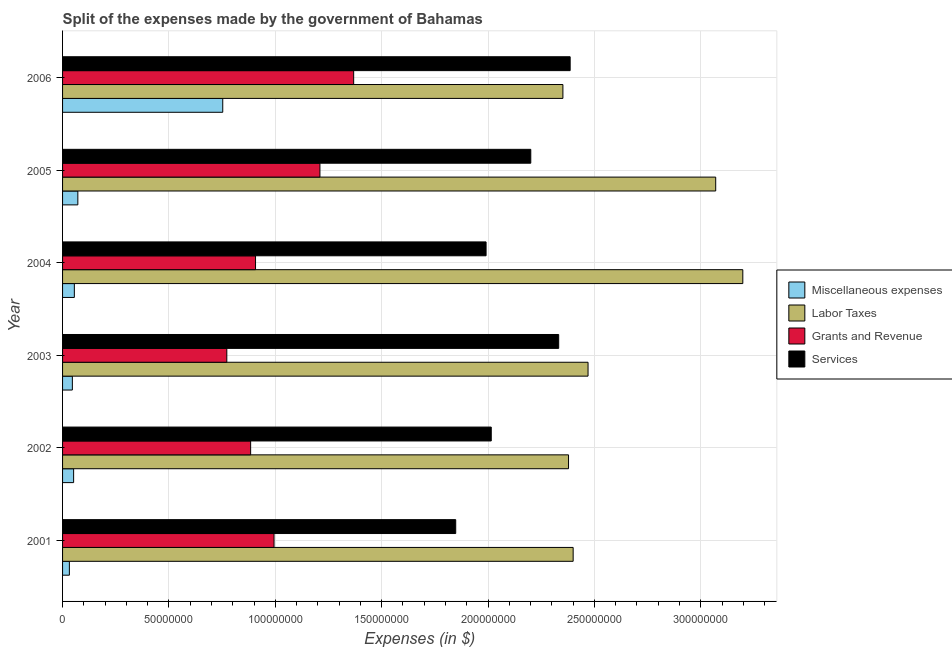Are the number of bars per tick equal to the number of legend labels?
Your response must be concise. Yes. How many bars are there on the 1st tick from the bottom?
Offer a very short reply. 4. In how many cases, is the number of bars for a given year not equal to the number of legend labels?
Your answer should be compact. 0. What is the amount spent on grants and revenue in 2005?
Provide a short and direct response. 1.21e+08. Across all years, what is the maximum amount spent on services?
Offer a very short reply. 2.39e+08. Across all years, what is the minimum amount spent on grants and revenue?
Ensure brevity in your answer.  7.72e+07. In which year was the amount spent on services minimum?
Make the answer very short. 2001. What is the total amount spent on miscellaneous expenses in the graph?
Your response must be concise. 1.01e+08. What is the difference between the amount spent on labor taxes in 2001 and that in 2003?
Your answer should be compact. -7.00e+06. What is the difference between the amount spent on services in 2003 and the amount spent on miscellaneous expenses in 2002?
Make the answer very short. 2.28e+08. What is the average amount spent on grants and revenue per year?
Keep it short and to the point. 1.02e+08. In the year 2005, what is the difference between the amount spent on grants and revenue and amount spent on services?
Your answer should be compact. -9.91e+07. In how many years, is the amount spent on services greater than 210000000 $?
Provide a short and direct response. 3. What is the ratio of the amount spent on miscellaneous expenses in 2001 to that in 2004?
Ensure brevity in your answer.  0.58. Is the amount spent on miscellaneous expenses in 2003 less than that in 2006?
Provide a succinct answer. Yes. Is the difference between the amount spent on services in 2001 and 2002 greater than the difference between the amount spent on grants and revenue in 2001 and 2002?
Offer a very short reply. No. What is the difference between the highest and the second highest amount spent on services?
Offer a very short reply. 5.39e+06. What is the difference between the highest and the lowest amount spent on miscellaneous expenses?
Your answer should be compact. 7.21e+07. What does the 2nd bar from the top in 2002 represents?
Your response must be concise. Grants and Revenue. What does the 1st bar from the bottom in 2001 represents?
Your response must be concise. Miscellaneous expenses. Is it the case that in every year, the sum of the amount spent on miscellaneous expenses and amount spent on labor taxes is greater than the amount spent on grants and revenue?
Make the answer very short. Yes. Are all the bars in the graph horizontal?
Provide a short and direct response. Yes. What is the difference between two consecutive major ticks on the X-axis?
Offer a terse response. 5.00e+07. Are the values on the major ticks of X-axis written in scientific E-notation?
Keep it short and to the point. No. Does the graph contain grids?
Provide a short and direct response. Yes. Where does the legend appear in the graph?
Provide a short and direct response. Center right. What is the title of the graph?
Your response must be concise. Split of the expenses made by the government of Bahamas. Does "Secondary vocational" appear as one of the legend labels in the graph?
Your response must be concise. No. What is the label or title of the X-axis?
Give a very brief answer. Expenses (in $). What is the label or title of the Y-axis?
Offer a terse response. Year. What is the Expenses (in $) in Miscellaneous expenses in 2001?
Provide a short and direct response. 3.20e+06. What is the Expenses (in $) in Labor Taxes in 2001?
Ensure brevity in your answer.  2.40e+08. What is the Expenses (in $) in Grants and Revenue in 2001?
Ensure brevity in your answer.  9.94e+07. What is the Expenses (in $) in Services in 2001?
Your answer should be compact. 1.85e+08. What is the Expenses (in $) of Miscellaneous expenses in 2002?
Offer a terse response. 5.20e+06. What is the Expenses (in $) in Labor Taxes in 2002?
Give a very brief answer. 2.38e+08. What is the Expenses (in $) in Grants and Revenue in 2002?
Provide a short and direct response. 8.84e+07. What is the Expenses (in $) of Services in 2002?
Keep it short and to the point. 2.02e+08. What is the Expenses (in $) in Miscellaneous expenses in 2003?
Offer a very short reply. 4.60e+06. What is the Expenses (in $) of Labor Taxes in 2003?
Offer a terse response. 2.47e+08. What is the Expenses (in $) of Grants and Revenue in 2003?
Keep it short and to the point. 7.72e+07. What is the Expenses (in $) in Services in 2003?
Offer a very short reply. 2.33e+08. What is the Expenses (in $) of Miscellaneous expenses in 2004?
Keep it short and to the point. 5.54e+06. What is the Expenses (in $) in Labor Taxes in 2004?
Provide a short and direct response. 3.20e+08. What is the Expenses (in $) of Grants and Revenue in 2004?
Your answer should be very brief. 9.07e+07. What is the Expenses (in $) of Services in 2004?
Your response must be concise. 1.99e+08. What is the Expenses (in $) of Miscellaneous expenses in 2005?
Offer a very short reply. 7.18e+06. What is the Expenses (in $) in Labor Taxes in 2005?
Make the answer very short. 3.07e+08. What is the Expenses (in $) in Grants and Revenue in 2005?
Your answer should be very brief. 1.21e+08. What is the Expenses (in $) of Services in 2005?
Ensure brevity in your answer.  2.20e+08. What is the Expenses (in $) of Miscellaneous expenses in 2006?
Your response must be concise. 7.53e+07. What is the Expenses (in $) in Labor Taxes in 2006?
Your answer should be compact. 2.35e+08. What is the Expenses (in $) of Grants and Revenue in 2006?
Offer a very short reply. 1.37e+08. What is the Expenses (in $) in Services in 2006?
Your answer should be compact. 2.39e+08. Across all years, what is the maximum Expenses (in $) in Miscellaneous expenses?
Ensure brevity in your answer.  7.53e+07. Across all years, what is the maximum Expenses (in $) in Labor Taxes?
Ensure brevity in your answer.  3.20e+08. Across all years, what is the maximum Expenses (in $) in Grants and Revenue?
Offer a terse response. 1.37e+08. Across all years, what is the maximum Expenses (in $) of Services?
Offer a very short reply. 2.39e+08. Across all years, what is the minimum Expenses (in $) of Miscellaneous expenses?
Your answer should be very brief. 3.20e+06. Across all years, what is the minimum Expenses (in $) of Labor Taxes?
Provide a succinct answer. 2.35e+08. Across all years, what is the minimum Expenses (in $) in Grants and Revenue?
Your response must be concise. 7.72e+07. Across all years, what is the minimum Expenses (in $) of Services?
Provide a short and direct response. 1.85e+08. What is the total Expenses (in $) of Miscellaneous expenses in the graph?
Provide a short and direct response. 1.01e+08. What is the total Expenses (in $) of Labor Taxes in the graph?
Your response must be concise. 1.59e+09. What is the total Expenses (in $) of Grants and Revenue in the graph?
Ensure brevity in your answer.  6.14e+08. What is the total Expenses (in $) in Services in the graph?
Offer a terse response. 1.28e+09. What is the difference between the Expenses (in $) of Miscellaneous expenses in 2001 and that in 2002?
Your answer should be compact. -2.00e+06. What is the difference between the Expenses (in $) in Labor Taxes in 2001 and that in 2002?
Keep it short and to the point. 2.18e+06. What is the difference between the Expenses (in $) in Grants and Revenue in 2001 and that in 2002?
Provide a short and direct response. 1.10e+07. What is the difference between the Expenses (in $) of Services in 2001 and that in 2002?
Make the answer very short. -1.67e+07. What is the difference between the Expenses (in $) of Miscellaneous expenses in 2001 and that in 2003?
Give a very brief answer. -1.40e+06. What is the difference between the Expenses (in $) in Labor Taxes in 2001 and that in 2003?
Give a very brief answer. -7.00e+06. What is the difference between the Expenses (in $) in Grants and Revenue in 2001 and that in 2003?
Your answer should be very brief. 2.22e+07. What is the difference between the Expenses (in $) in Services in 2001 and that in 2003?
Your answer should be compact. -4.84e+07. What is the difference between the Expenses (in $) in Miscellaneous expenses in 2001 and that in 2004?
Provide a succinct answer. -2.34e+06. What is the difference between the Expenses (in $) in Labor Taxes in 2001 and that in 2004?
Make the answer very short. -7.97e+07. What is the difference between the Expenses (in $) in Grants and Revenue in 2001 and that in 2004?
Provide a short and direct response. 8.70e+06. What is the difference between the Expenses (in $) in Services in 2001 and that in 2004?
Make the answer very short. -1.43e+07. What is the difference between the Expenses (in $) of Miscellaneous expenses in 2001 and that in 2005?
Keep it short and to the point. -3.98e+06. What is the difference between the Expenses (in $) of Labor Taxes in 2001 and that in 2005?
Offer a terse response. -6.70e+07. What is the difference between the Expenses (in $) in Grants and Revenue in 2001 and that in 2005?
Offer a terse response. -2.16e+07. What is the difference between the Expenses (in $) in Services in 2001 and that in 2005?
Your response must be concise. -3.53e+07. What is the difference between the Expenses (in $) in Miscellaneous expenses in 2001 and that in 2006?
Offer a very short reply. -7.21e+07. What is the difference between the Expenses (in $) in Labor Taxes in 2001 and that in 2006?
Offer a terse response. 4.82e+06. What is the difference between the Expenses (in $) in Grants and Revenue in 2001 and that in 2006?
Make the answer very short. -3.74e+07. What is the difference between the Expenses (in $) in Services in 2001 and that in 2006?
Provide a short and direct response. -5.38e+07. What is the difference between the Expenses (in $) in Labor Taxes in 2002 and that in 2003?
Your answer should be very brief. -9.18e+06. What is the difference between the Expenses (in $) of Grants and Revenue in 2002 and that in 2003?
Your answer should be compact. 1.12e+07. What is the difference between the Expenses (in $) of Services in 2002 and that in 2003?
Your answer should be very brief. -3.17e+07. What is the difference between the Expenses (in $) in Miscellaneous expenses in 2002 and that in 2004?
Keep it short and to the point. -3.39e+05. What is the difference between the Expenses (in $) of Labor Taxes in 2002 and that in 2004?
Offer a very short reply. -8.19e+07. What is the difference between the Expenses (in $) of Grants and Revenue in 2002 and that in 2004?
Offer a very short reply. -2.30e+06. What is the difference between the Expenses (in $) in Services in 2002 and that in 2004?
Ensure brevity in your answer.  2.43e+06. What is the difference between the Expenses (in $) in Miscellaneous expenses in 2002 and that in 2005?
Offer a terse response. -1.98e+06. What is the difference between the Expenses (in $) in Labor Taxes in 2002 and that in 2005?
Make the answer very short. -6.92e+07. What is the difference between the Expenses (in $) of Grants and Revenue in 2002 and that in 2005?
Give a very brief answer. -3.26e+07. What is the difference between the Expenses (in $) in Services in 2002 and that in 2005?
Keep it short and to the point. -1.86e+07. What is the difference between the Expenses (in $) of Miscellaneous expenses in 2002 and that in 2006?
Ensure brevity in your answer.  -7.01e+07. What is the difference between the Expenses (in $) in Labor Taxes in 2002 and that in 2006?
Ensure brevity in your answer.  2.64e+06. What is the difference between the Expenses (in $) of Grants and Revenue in 2002 and that in 2006?
Provide a succinct answer. -4.84e+07. What is the difference between the Expenses (in $) of Services in 2002 and that in 2006?
Offer a terse response. -3.71e+07. What is the difference between the Expenses (in $) in Miscellaneous expenses in 2003 and that in 2004?
Your answer should be very brief. -9.39e+05. What is the difference between the Expenses (in $) in Labor Taxes in 2003 and that in 2004?
Provide a short and direct response. -7.27e+07. What is the difference between the Expenses (in $) in Grants and Revenue in 2003 and that in 2004?
Your response must be concise. -1.35e+07. What is the difference between the Expenses (in $) of Services in 2003 and that in 2004?
Offer a terse response. 3.41e+07. What is the difference between the Expenses (in $) in Miscellaneous expenses in 2003 and that in 2005?
Your response must be concise. -2.58e+06. What is the difference between the Expenses (in $) of Labor Taxes in 2003 and that in 2005?
Make the answer very short. -6.00e+07. What is the difference between the Expenses (in $) of Grants and Revenue in 2003 and that in 2005?
Your answer should be compact. -4.38e+07. What is the difference between the Expenses (in $) of Services in 2003 and that in 2005?
Give a very brief answer. 1.31e+07. What is the difference between the Expenses (in $) in Miscellaneous expenses in 2003 and that in 2006?
Provide a succinct answer. -7.07e+07. What is the difference between the Expenses (in $) of Labor Taxes in 2003 and that in 2006?
Your answer should be very brief. 1.18e+07. What is the difference between the Expenses (in $) in Grants and Revenue in 2003 and that in 2006?
Make the answer very short. -5.96e+07. What is the difference between the Expenses (in $) in Services in 2003 and that in 2006?
Keep it short and to the point. -5.39e+06. What is the difference between the Expenses (in $) of Miscellaneous expenses in 2004 and that in 2005?
Your response must be concise. -1.64e+06. What is the difference between the Expenses (in $) in Labor Taxes in 2004 and that in 2005?
Give a very brief answer. 1.27e+07. What is the difference between the Expenses (in $) in Grants and Revenue in 2004 and that in 2005?
Make the answer very short. -3.03e+07. What is the difference between the Expenses (in $) in Services in 2004 and that in 2005?
Ensure brevity in your answer.  -2.10e+07. What is the difference between the Expenses (in $) in Miscellaneous expenses in 2004 and that in 2006?
Provide a short and direct response. -6.98e+07. What is the difference between the Expenses (in $) of Labor Taxes in 2004 and that in 2006?
Ensure brevity in your answer.  8.46e+07. What is the difference between the Expenses (in $) in Grants and Revenue in 2004 and that in 2006?
Keep it short and to the point. -4.61e+07. What is the difference between the Expenses (in $) of Services in 2004 and that in 2006?
Offer a terse response. -3.95e+07. What is the difference between the Expenses (in $) in Miscellaneous expenses in 2005 and that in 2006?
Your answer should be compact. -6.81e+07. What is the difference between the Expenses (in $) in Labor Taxes in 2005 and that in 2006?
Your response must be concise. 7.18e+07. What is the difference between the Expenses (in $) of Grants and Revenue in 2005 and that in 2006?
Your answer should be compact. -1.59e+07. What is the difference between the Expenses (in $) in Services in 2005 and that in 2006?
Ensure brevity in your answer.  -1.85e+07. What is the difference between the Expenses (in $) in Miscellaneous expenses in 2001 and the Expenses (in $) in Labor Taxes in 2002?
Offer a very short reply. -2.35e+08. What is the difference between the Expenses (in $) in Miscellaneous expenses in 2001 and the Expenses (in $) in Grants and Revenue in 2002?
Offer a terse response. -8.52e+07. What is the difference between the Expenses (in $) in Miscellaneous expenses in 2001 and the Expenses (in $) in Services in 2002?
Make the answer very short. -1.98e+08. What is the difference between the Expenses (in $) in Labor Taxes in 2001 and the Expenses (in $) in Grants and Revenue in 2002?
Offer a very short reply. 1.52e+08. What is the difference between the Expenses (in $) in Labor Taxes in 2001 and the Expenses (in $) in Services in 2002?
Offer a very short reply. 3.85e+07. What is the difference between the Expenses (in $) of Grants and Revenue in 2001 and the Expenses (in $) of Services in 2002?
Your answer should be very brief. -1.02e+08. What is the difference between the Expenses (in $) of Miscellaneous expenses in 2001 and the Expenses (in $) of Labor Taxes in 2003?
Keep it short and to the point. -2.44e+08. What is the difference between the Expenses (in $) of Miscellaneous expenses in 2001 and the Expenses (in $) of Grants and Revenue in 2003?
Make the answer very short. -7.40e+07. What is the difference between the Expenses (in $) of Miscellaneous expenses in 2001 and the Expenses (in $) of Services in 2003?
Give a very brief answer. -2.30e+08. What is the difference between the Expenses (in $) of Labor Taxes in 2001 and the Expenses (in $) of Grants and Revenue in 2003?
Keep it short and to the point. 1.63e+08. What is the difference between the Expenses (in $) in Labor Taxes in 2001 and the Expenses (in $) in Services in 2003?
Provide a succinct answer. 6.80e+06. What is the difference between the Expenses (in $) in Grants and Revenue in 2001 and the Expenses (in $) in Services in 2003?
Make the answer very short. -1.34e+08. What is the difference between the Expenses (in $) of Miscellaneous expenses in 2001 and the Expenses (in $) of Labor Taxes in 2004?
Provide a succinct answer. -3.17e+08. What is the difference between the Expenses (in $) of Miscellaneous expenses in 2001 and the Expenses (in $) of Grants and Revenue in 2004?
Give a very brief answer. -8.75e+07. What is the difference between the Expenses (in $) in Miscellaneous expenses in 2001 and the Expenses (in $) in Services in 2004?
Provide a short and direct response. -1.96e+08. What is the difference between the Expenses (in $) of Labor Taxes in 2001 and the Expenses (in $) of Grants and Revenue in 2004?
Provide a succinct answer. 1.49e+08. What is the difference between the Expenses (in $) in Labor Taxes in 2001 and the Expenses (in $) in Services in 2004?
Provide a short and direct response. 4.09e+07. What is the difference between the Expenses (in $) in Grants and Revenue in 2001 and the Expenses (in $) in Services in 2004?
Provide a short and direct response. -9.97e+07. What is the difference between the Expenses (in $) in Miscellaneous expenses in 2001 and the Expenses (in $) in Labor Taxes in 2005?
Offer a very short reply. -3.04e+08. What is the difference between the Expenses (in $) of Miscellaneous expenses in 2001 and the Expenses (in $) of Grants and Revenue in 2005?
Provide a succinct answer. -1.18e+08. What is the difference between the Expenses (in $) of Miscellaneous expenses in 2001 and the Expenses (in $) of Services in 2005?
Provide a succinct answer. -2.17e+08. What is the difference between the Expenses (in $) of Labor Taxes in 2001 and the Expenses (in $) of Grants and Revenue in 2005?
Offer a very short reply. 1.19e+08. What is the difference between the Expenses (in $) in Labor Taxes in 2001 and the Expenses (in $) in Services in 2005?
Ensure brevity in your answer.  1.99e+07. What is the difference between the Expenses (in $) in Grants and Revenue in 2001 and the Expenses (in $) in Services in 2005?
Your response must be concise. -1.21e+08. What is the difference between the Expenses (in $) of Miscellaneous expenses in 2001 and the Expenses (in $) of Labor Taxes in 2006?
Make the answer very short. -2.32e+08. What is the difference between the Expenses (in $) of Miscellaneous expenses in 2001 and the Expenses (in $) of Grants and Revenue in 2006?
Provide a short and direct response. -1.34e+08. What is the difference between the Expenses (in $) in Miscellaneous expenses in 2001 and the Expenses (in $) in Services in 2006?
Ensure brevity in your answer.  -2.35e+08. What is the difference between the Expenses (in $) of Labor Taxes in 2001 and the Expenses (in $) of Grants and Revenue in 2006?
Ensure brevity in your answer.  1.03e+08. What is the difference between the Expenses (in $) in Labor Taxes in 2001 and the Expenses (in $) in Services in 2006?
Provide a succinct answer. 1.41e+06. What is the difference between the Expenses (in $) in Grants and Revenue in 2001 and the Expenses (in $) in Services in 2006?
Provide a succinct answer. -1.39e+08. What is the difference between the Expenses (in $) of Miscellaneous expenses in 2002 and the Expenses (in $) of Labor Taxes in 2003?
Provide a short and direct response. -2.42e+08. What is the difference between the Expenses (in $) in Miscellaneous expenses in 2002 and the Expenses (in $) in Grants and Revenue in 2003?
Offer a very short reply. -7.20e+07. What is the difference between the Expenses (in $) in Miscellaneous expenses in 2002 and the Expenses (in $) in Services in 2003?
Provide a succinct answer. -2.28e+08. What is the difference between the Expenses (in $) in Labor Taxes in 2002 and the Expenses (in $) in Grants and Revenue in 2003?
Ensure brevity in your answer.  1.61e+08. What is the difference between the Expenses (in $) of Labor Taxes in 2002 and the Expenses (in $) of Services in 2003?
Make the answer very short. 4.62e+06. What is the difference between the Expenses (in $) in Grants and Revenue in 2002 and the Expenses (in $) in Services in 2003?
Give a very brief answer. -1.45e+08. What is the difference between the Expenses (in $) of Miscellaneous expenses in 2002 and the Expenses (in $) of Labor Taxes in 2004?
Offer a terse response. -3.15e+08. What is the difference between the Expenses (in $) in Miscellaneous expenses in 2002 and the Expenses (in $) in Grants and Revenue in 2004?
Offer a very short reply. -8.55e+07. What is the difference between the Expenses (in $) in Miscellaneous expenses in 2002 and the Expenses (in $) in Services in 2004?
Provide a succinct answer. -1.94e+08. What is the difference between the Expenses (in $) of Labor Taxes in 2002 and the Expenses (in $) of Grants and Revenue in 2004?
Your answer should be compact. 1.47e+08. What is the difference between the Expenses (in $) in Labor Taxes in 2002 and the Expenses (in $) in Services in 2004?
Give a very brief answer. 3.88e+07. What is the difference between the Expenses (in $) in Grants and Revenue in 2002 and the Expenses (in $) in Services in 2004?
Your response must be concise. -1.11e+08. What is the difference between the Expenses (in $) of Miscellaneous expenses in 2002 and the Expenses (in $) of Labor Taxes in 2005?
Your response must be concise. -3.02e+08. What is the difference between the Expenses (in $) of Miscellaneous expenses in 2002 and the Expenses (in $) of Grants and Revenue in 2005?
Your response must be concise. -1.16e+08. What is the difference between the Expenses (in $) in Miscellaneous expenses in 2002 and the Expenses (in $) in Services in 2005?
Offer a very short reply. -2.15e+08. What is the difference between the Expenses (in $) in Labor Taxes in 2002 and the Expenses (in $) in Grants and Revenue in 2005?
Give a very brief answer. 1.17e+08. What is the difference between the Expenses (in $) in Labor Taxes in 2002 and the Expenses (in $) in Services in 2005?
Your response must be concise. 1.77e+07. What is the difference between the Expenses (in $) in Grants and Revenue in 2002 and the Expenses (in $) in Services in 2005?
Provide a short and direct response. -1.32e+08. What is the difference between the Expenses (in $) in Miscellaneous expenses in 2002 and the Expenses (in $) in Labor Taxes in 2006?
Give a very brief answer. -2.30e+08. What is the difference between the Expenses (in $) of Miscellaneous expenses in 2002 and the Expenses (in $) of Grants and Revenue in 2006?
Your answer should be very brief. -1.32e+08. What is the difference between the Expenses (in $) of Miscellaneous expenses in 2002 and the Expenses (in $) of Services in 2006?
Ensure brevity in your answer.  -2.33e+08. What is the difference between the Expenses (in $) of Labor Taxes in 2002 and the Expenses (in $) of Grants and Revenue in 2006?
Offer a terse response. 1.01e+08. What is the difference between the Expenses (in $) in Labor Taxes in 2002 and the Expenses (in $) in Services in 2006?
Your answer should be very brief. -7.69e+05. What is the difference between the Expenses (in $) of Grants and Revenue in 2002 and the Expenses (in $) of Services in 2006?
Keep it short and to the point. -1.50e+08. What is the difference between the Expenses (in $) in Miscellaneous expenses in 2003 and the Expenses (in $) in Labor Taxes in 2004?
Give a very brief answer. -3.15e+08. What is the difference between the Expenses (in $) in Miscellaneous expenses in 2003 and the Expenses (in $) in Grants and Revenue in 2004?
Give a very brief answer. -8.61e+07. What is the difference between the Expenses (in $) in Miscellaneous expenses in 2003 and the Expenses (in $) in Services in 2004?
Offer a terse response. -1.94e+08. What is the difference between the Expenses (in $) of Labor Taxes in 2003 and the Expenses (in $) of Grants and Revenue in 2004?
Make the answer very short. 1.56e+08. What is the difference between the Expenses (in $) of Labor Taxes in 2003 and the Expenses (in $) of Services in 2004?
Ensure brevity in your answer.  4.79e+07. What is the difference between the Expenses (in $) of Grants and Revenue in 2003 and the Expenses (in $) of Services in 2004?
Keep it short and to the point. -1.22e+08. What is the difference between the Expenses (in $) in Miscellaneous expenses in 2003 and the Expenses (in $) in Labor Taxes in 2005?
Ensure brevity in your answer.  -3.02e+08. What is the difference between the Expenses (in $) in Miscellaneous expenses in 2003 and the Expenses (in $) in Grants and Revenue in 2005?
Keep it short and to the point. -1.16e+08. What is the difference between the Expenses (in $) in Miscellaneous expenses in 2003 and the Expenses (in $) in Services in 2005?
Offer a very short reply. -2.15e+08. What is the difference between the Expenses (in $) of Labor Taxes in 2003 and the Expenses (in $) of Grants and Revenue in 2005?
Provide a succinct answer. 1.26e+08. What is the difference between the Expenses (in $) in Labor Taxes in 2003 and the Expenses (in $) in Services in 2005?
Provide a succinct answer. 2.69e+07. What is the difference between the Expenses (in $) of Grants and Revenue in 2003 and the Expenses (in $) of Services in 2005?
Provide a short and direct response. -1.43e+08. What is the difference between the Expenses (in $) of Miscellaneous expenses in 2003 and the Expenses (in $) of Labor Taxes in 2006?
Keep it short and to the point. -2.31e+08. What is the difference between the Expenses (in $) of Miscellaneous expenses in 2003 and the Expenses (in $) of Grants and Revenue in 2006?
Offer a very short reply. -1.32e+08. What is the difference between the Expenses (in $) of Miscellaneous expenses in 2003 and the Expenses (in $) of Services in 2006?
Offer a terse response. -2.34e+08. What is the difference between the Expenses (in $) of Labor Taxes in 2003 and the Expenses (in $) of Grants and Revenue in 2006?
Make the answer very short. 1.10e+08. What is the difference between the Expenses (in $) in Labor Taxes in 2003 and the Expenses (in $) in Services in 2006?
Give a very brief answer. 8.41e+06. What is the difference between the Expenses (in $) of Grants and Revenue in 2003 and the Expenses (in $) of Services in 2006?
Make the answer very short. -1.61e+08. What is the difference between the Expenses (in $) of Miscellaneous expenses in 2004 and the Expenses (in $) of Labor Taxes in 2005?
Make the answer very short. -3.01e+08. What is the difference between the Expenses (in $) in Miscellaneous expenses in 2004 and the Expenses (in $) in Grants and Revenue in 2005?
Give a very brief answer. -1.15e+08. What is the difference between the Expenses (in $) of Miscellaneous expenses in 2004 and the Expenses (in $) of Services in 2005?
Provide a succinct answer. -2.15e+08. What is the difference between the Expenses (in $) in Labor Taxes in 2004 and the Expenses (in $) in Grants and Revenue in 2005?
Your answer should be very brief. 1.99e+08. What is the difference between the Expenses (in $) of Labor Taxes in 2004 and the Expenses (in $) of Services in 2005?
Your response must be concise. 9.97e+07. What is the difference between the Expenses (in $) of Grants and Revenue in 2004 and the Expenses (in $) of Services in 2005?
Offer a very short reply. -1.29e+08. What is the difference between the Expenses (in $) of Miscellaneous expenses in 2004 and the Expenses (in $) of Labor Taxes in 2006?
Keep it short and to the point. -2.30e+08. What is the difference between the Expenses (in $) in Miscellaneous expenses in 2004 and the Expenses (in $) in Grants and Revenue in 2006?
Your answer should be very brief. -1.31e+08. What is the difference between the Expenses (in $) in Miscellaneous expenses in 2004 and the Expenses (in $) in Services in 2006?
Make the answer very short. -2.33e+08. What is the difference between the Expenses (in $) in Labor Taxes in 2004 and the Expenses (in $) in Grants and Revenue in 2006?
Provide a succinct answer. 1.83e+08. What is the difference between the Expenses (in $) of Labor Taxes in 2004 and the Expenses (in $) of Services in 2006?
Offer a very short reply. 8.12e+07. What is the difference between the Expenses (in $) of Grants and Revenue in 2004 and the Expenses (in $) of Services in 2006?
Ensure brevity in your answer.  -1.48e+08. What is the difference between the Expenses (in $) of Miscellaneous expenses in 2005 and the Expenses (in $) of Labor Taxes in 2006?
Give a very brief answer. -2.28e+08. What is the difference between the Expenses (in $) in Miscellaneous expenses in 2005 and the Expenses (in $) in Grants and Revenue in 2006?
Your answer should be very brief. -1.30e+08. What is the difference between the Expenses (in $) of Miscellaneous expenses in 2005 and the Expenses (in $) of Services in 2006?
Ensure brevity in your answer.  -2.31e+08. What is the difference between the Expenses (in $) of Labor Taxes in 2005 and the Expenses (in $) of Grants and Revenue in 2006?
Ensure brevity in your answer.  1.70e+08. What is the difference between the Expenses (in $) in Labor Taxes in 2005 and the Expenses (in $) in Services in 2006?
Your response must be concise. 6.84e+07. What is the difference between the Expenses (in $) in Grants and Revenue in 2005 and the Expenses (in $) in Services in 2006?
Offer a terse response. -1.18e+08. What is the average Expenses (in $) of Miscellaneous expenses per year?
Give a very brief answer. 1.68e+07. What is the average Expenses (in $) of Labor Taxes per year?
Give a very brief answer. 2.64e+08. What is the average Expenses (in $) of Grants and Revenue per year?
Keep it short and to the point. 1.02e+08. What is the average Expenses (in $) of Services per year?
Provide a short and direct response. 2.13e+08. In the year 2001, what is the difference between the Expenses (in $) of Miscellaneous expenses and Expenses (in $) of Labor Taxes?
Offer a terse response. -2.37e+08. In the year 2001, what is the difference between the Expenses (in $) in Miscellaneous expenses and Expenses (in $) in Grants and Revenue?
Give a very brief answer. -9.62e+07. In the year 2001, what is the difference between the Expenses (in $) in Miscellaneous expenses and Expenses (in $) in Services?
Make the answer very short. -1.82e+08. In the year 2001, what is the difference between the Expenses (in $) of Labor Taxes and Expenses (in $) of Grants and Revenue?
Offer a terse response. 1.41e+08. In the year 2001, what is the difference between the Expenses (in $) of Labor Taxes and Expenses (in $) of Services?
Your response must be concise. 5.52e+07. In the year 2001, what is the difference between the Expenses (in $) of Grants and Revenue and Expenses (in $) of Services?
Keep it short and to the point. -8.54e+07. In the year 2002, what is the difference between the Expenses (in $) of Miscellaneous expenses and Expenses (in $) of Labor Taxes?
Offer a terse response. -2.33e+08. In the year 2002, what is the difference between the Expenses (in $) of Miscellaneous expenses and Expenses (in $) of Grants and Revenue?
Provide a short and direct response. -8.32e+07. In the year 2002, what is the difference between the Expenses (in $) of Miscellaneous expenses and Expenses (in $) of Services?
Give a very brief answer. -1.96e+08. In the year 2002, what is the difference between the Expenses (in $) in Labor Taxes and Expenses (in $) in Grants and Revenue?
Keep it short and to the point. 1.49e+08. In the year 2002, what is the difference between the Expenses (in $) of Labor Taxes and Expenses (in $) of Services?
Provide a succinct answer. 3.63e+07. In the year 2002, what is the difference between the Expenses (in $) of Grants and Revenue and Expenses (in $) of Services?
Your answer should be compact. -1.13e+08. In the year 2003, what is the difference between the Expenses (in $) in Miscellaneous expenses and Expenses (in $) in Labor Taxes?
Provide a short and direct response. -2.42e+08. In the year 2003, what is the difference between the Expenses (in $) in Miscellaneous expenses and Expenses (in $) in Grants and Revenue?
Keep it short and to the point. -7.26e+07. In the year 2003, what is the difference between the Expenses (in $) of Miscellaneous expenses and Expenses (in $) of Services?
Give a very brief answer. -2.29e+08. In the year 2003, what is the difference between the Expenses (in $) of Labor Taxes and Expenses (in $) of Grants and Revenue?
Offer a very short reply. 1.70e+08. In the year 2003, what is the difference between the Expenses (in $) of Labor Taxes and Expenses (in $) of Services?
Your response must be concise. 1.38e+07. In the year 2003, what is the difference between the Expenses (in $) of Grants and Revenue and Expenses (in $) of Services?
Offer a terse response. -1.56e+08. In the year 2004, what is the difference between the Expenses (in $) in Miscellaneous expenses and Expenses (in $) in Labor Taxes?
Ensure brevity in your answer.  -3.14e+08. In the year 2004, what is the difference between the Expenses (in $) of Miscellaneous expenses and Expenses (in $) of Grants and Revenue?
Make the answer very short. -8.52e+07. In the year 2004, what is the difference between the Expenses (in $) of Miscellaneous expenses and Expenses (in $) of Services?
Your response must be concise. -1.94e+08. In the year 2004, what is the difference between the Expenses (in $) in Labor Taxes and Expenses (in $) in Grants and Revenue?
Provide a succinct answer. 2.29e+08. In the year 2004, what is the difference between the Expenses (in $) of Labor Taxes and Expenses (in $) of Services?
Offer a very short reply. 1.21e+08. In the year 2004, what is the difference between the Expenses (in $) in Grants and Revenue and Expenses (in $) in Services?
Offer a terse response. -1.08e+08. In the year 2005, what is the difference between the Expenses (in $) of Miscellaneous expenses and Expenses (in $) of Labor Taxes?
Ensure brevity in your answer.  -3.00e+08. In the year 2005, what is the difference between the Expenses (in $) of Miscellaneous expenses and Expenses (in $) of Grants and Revenue?
Your response must be concise. -1.14e+08. In the year 2005, what is the difference between the Expenses (in $) in Miscellaneous expenses and Expenses (in $) in Services?
Provide a succinct answer. -2.13e+08. In the year 2005, what is the difference between the Expenses (in $) in Labor Taxes and Expenses (in $) in Grants and Revenue?
Your answer should be compact. 1.86e+08. In the year 2005, what is the difference between the Expenses (in $) of Labor Taxes and Expenses (in $) of Services?
Provide a short and direct response. 8.69e+07. In the year 2005, what is the difference between the Expenses (in $) of Grants and Revenue and Expenses (in $) of Services?
Offer a very short reply. -9.91e+07. In the year 2006, what is the difference between the Expenses (in $) in Miscellaneous expenses and Expenses (in $) in Labor Taxes?
Your answer should be very brief. -1.60e+08. In the year 2006, what is the difference between the Expenses (in $) in Miscellaneous expenses and Expenses (in $) in Grants and Revenue?
Your answer should be very brief. -6.15e+07. In the year 2006, what is the difference between the Expenses (in $) in Miscellaneous expenses and Expenses (in $) in Services?
Provide a short and direct response. -1.63e+08. In the year 2006, what is the difference between the Expenses (in $) in Labor Taxes and Expenses (in $) in Grants and Revenue?
Your answer should be very brief. 9.84e+07. In the year 2006, what is the difference between the Expenses (in $) in Labor Taxes and Expenses (in $) in Services?
Provide a succinct answer. -3.41e+06. In the year 2006, what is the difference between the Expenses (in $) in Grants and Revenue and Expenses (in $) in Services?
Keep it short and to the point. -1.02e+08. What is the ratio of the Expenses (in $) of Miscellaneous expenses in 2001 to that in 2002?
Ensure brevity in your answer.  0.62. What is the ratio of the Expenses (in $) in Labor Taxes in 2001 to that in 2002?
Offer a very short reply. 1.01. What is the ratio of the Expenses (in $) of Grants and Revenue in 2001 to that in 2002?
Ensure brevity in your answer.  1.12. What is the ratio of the Expenses (in $) of Services in 2001 to that in 2002?
Provide a short and direct response. 0.92. What is the ratio of the Expenses (in $) of Miscellaneous expenses in 2001 to that in 2003?
Give a very brief answer. 0.7. What is the ratio of the Expenses (in $) in Labor Taxes in 2001 to that in 2003?
Your answer should be very brief. 0.97. What is the ratio of the Expenses (in $) in Grants and Revenue in 2001 to that in 2003?
Your answer should be compact. 1.29. What is the ratio of the Expenses (in $) of Services in 2001 to that in 2003?
Give a very brief answer. 0.79. What is the ratio of the Expenses (in $) of Miscellaneous expenses in 2001 to that in 2004?
Your response must be concise. 0.58. What is the ratio of the Expenses (in $) in Labor Taxes in 2001 to that in 2004?
Provide a short and direct response. 0.75. What is the ratio of the Expenses (in $) in Grants and Revenue in 2001 to that in 2004?
Keep it short and to the point. 1.1. What is the ratio of the Expenses (in $) of Services in 2001 to that in 2004?
Offer a terse response. 0.93. What is the ratio of the Expenses (in $) of Miscellaneous expenses in 2001 to that in 2005?
Make the answer very short. 0.45. What is the ratio of the Expenses (in $) of Labor Taxes in 2001 to that in 2005?
Give a very brief answer. 0.78. What is the ratio of the Expenses (in $) in Grants and Revenue in 2001 to that in 2005?
Offer a very short reply. 0.82. What is the ratio of the Expenses (in $) of Services in 2001 to that in 2005?
Keep it short and to the point. 0.84. What is the ratio of the Expenses (in $) of Miscellaneous expenses in 2001 to that in 2006?
Give a very brief answer. 0.04. What is the ratio of the Expenses (in $) in Labor Taxes in 2001 to that in 2006?
Give a very brief answer. 1.02. What is the ratio of the Expenses (in $) of Grants and Revenue in 2001 to that in 2006?
Provide a short and direct response. 0.73. What is the ratio of the Expenses (in $) of Services in 2001 to that in 2006?
Offer a very short reply. 0.77. What is the ratio of the Expenses (in $) of Miscellaneous expenses in 2002 to that in 2003?
Provide a short and direct response. 1.13. What is the ratio of the Expenses (in $) in Labor Taxes in 2002 to that in 2003?
Offer a very short reply. 0.96. What is the ratio of the Expenses (in $) of Grants and Revenue in 2002 to that in 2003?
Your answer should be compact. 1.15. What is the ratio of the Expenses (in $) in Services in 2002 to that in 2003?
Keep it short and to the point. 0.86. What is the ratio of the Expenses (in $) of Miscellaneous expenses in 2002 to that in 2004?
Offer a very short reply. 0.94. What is the ratio of the Expenses (in $) in Labor Taxes in 2002 to that in 2004?
Your answer should be very brief. 0.74. What is the ratio of the Expenses (in $) in Grants and Revenue in 2002 to that in 2004?
Offer a very short reply. 0.97. What is the ratio of the Expenses (in $) in Services in 2002 to that in 2004?
Your response must be concise. 1.01. What is the ratio of the Expenses (in $) in Miscellaneous expenses in 2002 to that in 2005?
Offer a terse response. 0.72. What is the ratio of the Expenses (in $) of Labor Taxes in 2002 to that in 2005?
Offer a terse response. 0.77. What is the ratio of the Expenses (in $) of Grants and Revenue in 2002 to that in 2005?
Make the answer very short. 0.73. What is the ratio of the Expenses (in $) of Services in 2002 to that in 2005?
Provide a short and direct response. 0.92. What is the ratio of the Expenses (in $) of Miscellaneous expenses in 2002 to that in 2006?
Give a very brief answer. 0.07. What is the ratio of the Expenses (in $) of Labor Taxes in 2002 to that in 2006?
Give a very brief answer. 1.01. What is the ratio of the Expenses (in $) of Grants and Revenue in 2002 to that in 2006?
Provide a short and direct response. 0.65. What is the ratio of the Expenses (in $) in Services in 2002 to that in 2006?
Make the answer very short. 0.84. What is the ratio of the Expenses (in $) of Miscellaneous expenses in 2003 to that in 2004?
Your response must be concise. 0.83. What is the ratio of the Expenses (in $) in Labor Taxes in 2003 to that in 2004?
Make the answer very short. 0.77. What is the ratio of the Expenses (in $) in Grants and Revenue in 2003 to that in 2004?
Offer a terse response. 0.85. What is the ratio of the Expenses (in $) of Services in 2003 to that in 2004?
Ensure brevity in your answer.  1.17. What is the ratio of the Expenses (in $) in Miscellaneous expenses in 2003 to that in 2005?
Ensure brevity in your answer.  0.64. What is the ratio of the Expenses (in $) of Labor Taxes in 2003 to that in 2005?
Keep it short and to the point. 0.8. What is the ratio of the Expenses (in $) of Grants and Revenue in 2003 to that in 2005?
Keep it short and to the point. 0.64. What is the ratio of the Expenses (in $) of Services in 2003 to that in 2005?
Make the answer very short. 1.06. What is the ratio of the Expenses (in $) in Miscellaneous expenses in 2003 to that in 2006?
Provide a short and direct response. 0.06. What is the ratio of the Expenses (in $) of Labor Taxes in 2003 to that in 2006?
Provide a succinct answer. 1.05. What is the ratio of the Expenses (in $) in Grants and Revenue in 2003 to that in 2006?
Your response must be concise. 0.56. What is the ratio of the Expenses (in $) of Services in 2003 to that in 2006?
Ensure brevity in your answer.  0.98. What is the ratio of the Expenses (in $) of Miscellaneous expenses in 2004 to that in 2005?
Your answer should be compact. 0.77. What is the ratio of the Expenses (in $) in Labor Taxes in 2004 to that in 2005?
Your response must be concise. 1.04. What is the ratio of the Expenses (in $) of Grants and Revenue in 2004 to that in 2005?
Offer a terse response. 0.75. What is the ratio of the Expenses (in $) of Services in 2004 to that in 2005?
Give a very brief answer. 0.9. What is the ratio of the Expenses (in $) in Miscellaneous expenses in 2004 to that in 2006?
Offer a terse response. 0.07. What is the ratio of the Expenses (in $) in Labor Taxes in 2004 to that in 2006?
Offer a very short reply. 1.36. What is the ratio of the Expenses (in $) of Grants and Revenue in 2004 to that in 2006?
Provide a short and direct response. 0.66. What is the ratio of the Expenses (in $) of Services in 2004 to that in 2006?
Keep it short and to the point. 0.83. What is the ratio of the Expenses (in $) in Miscellaneous expenses in 2005 to that in 2006?
Keep it short and to the point. 0.1. What is the ratio of the Expenses (in $) of Labor Taxes in 2005 to that in 2006?
Your answer should be compact. 1.31. What is the ratio of the Expenses (in $) of Grants and Revenue in 2005 to that in 2006?
Your response must be concise. 0.88. What is the ratio of the Expenses (in $) of Services in 2005 to that in 2006?
Ensure brevity in your answer.  0.92. What is the difference between the highest and the second highest Expenses (in $) of Miscellaneous expenses?
Provide a succinct answer. 6.81e+07. What is the difference between the highest and the second highest Expenses (in $) of Labor Taxes?
Provide a succinct answer. 1.27e+07. What is the difference between the highest and the second highest Expenses (in $) in Grants and Revenue?
Your response must be concise. 1.59e+07. What is the difference between the highest and the second highest Expenses (in $) of Services?
Keep it short and to the point. 5.39e+06. What is the difference between the highest and the lowest Expenses (in $) of Miscellaneous expenses?
Offer a very short reply. 7.21e+07. What is the difference between the highest and the lowest Expenses (in $) of Labor Taxes?
Offer a very short reply. 8.46e+07. What is the difference between the highest and the lowest Expenses (in $) in Grants and Revenue?
Your response must be concise. 5.96e+07. What is the difference between the highest and the lowest Expenses (in $) in Services?
Give a very brief answer. 5.38e+07. 